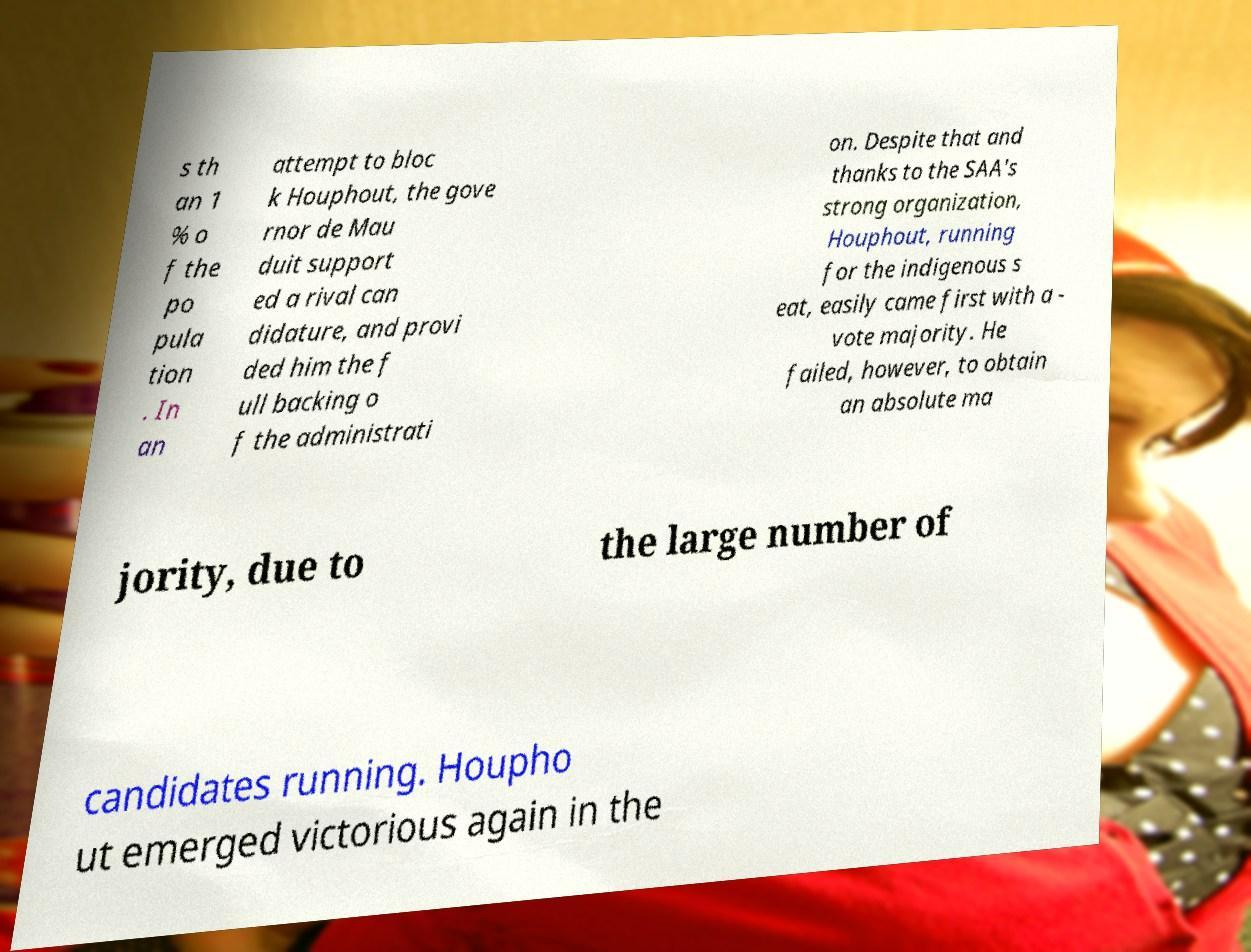There's text embedded in this image that I need extracted. Can you transcribe it verbatim? s th an 1 % o f the po pula tion . In an attempt to bloc k Houphout, the gove rnor de Mau duit support ed a rival can didature, and provi ded him the f ull backing o f the administrati on. Despite that and thanks to the SAA's strong organization, Houphout, running for the indigenous s eat, easily came first with a - vote majority. He failed, however, to obtain an absolute ma jority, due to the large number of candidates running. Houpho ut emerged victorious again in the 